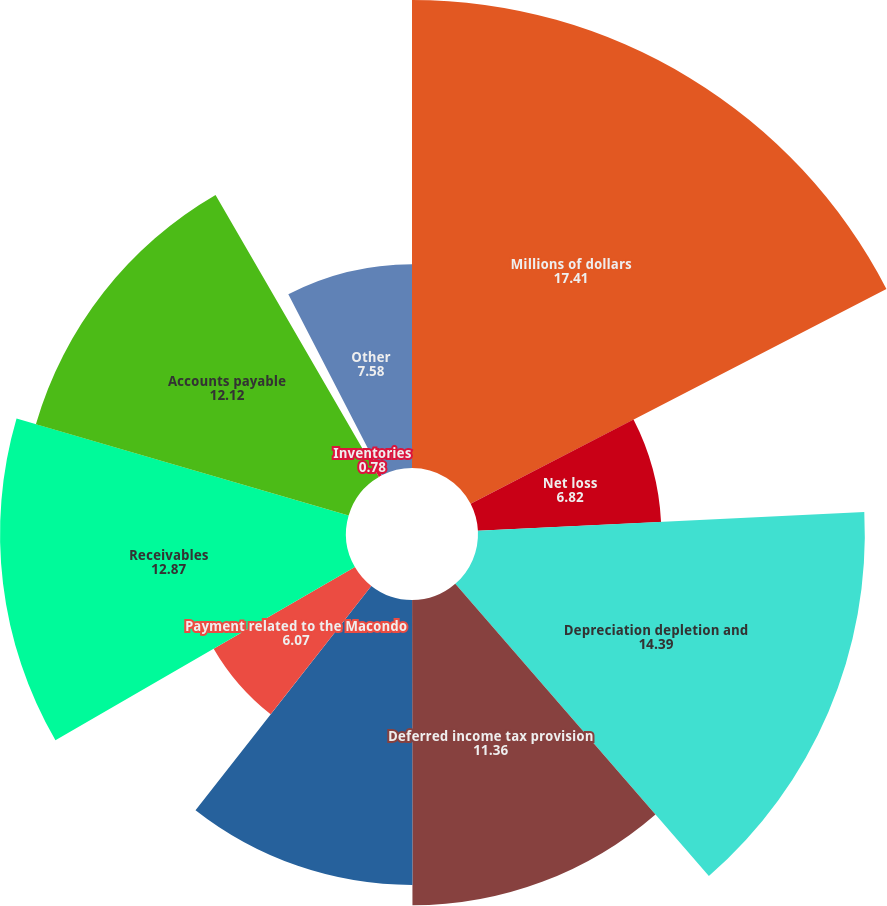Convert chart. <chart><loc_0><loc_0><loc_500><loc_500><pie_chart><fcel>Millions of dollars<fcel>Net loss<fcel>Depreciation depletion and<fcel>Deferred income tax provision<fcel>Impairments and other charges<fcel>Payment related to the Macondo<fcel>Receivables<fcel>Accounts payable<fcel>Inventories<fcel>Other<nl><fcel>17.41%<fcel>6.82%<fcel>14.39%<fcel>11.36%<fcel>10.6%<fcel>6.07%<fcel>12.87%<fcel>12.12%<fcel>0.78%<fcel>7.58%<nl></chart> 